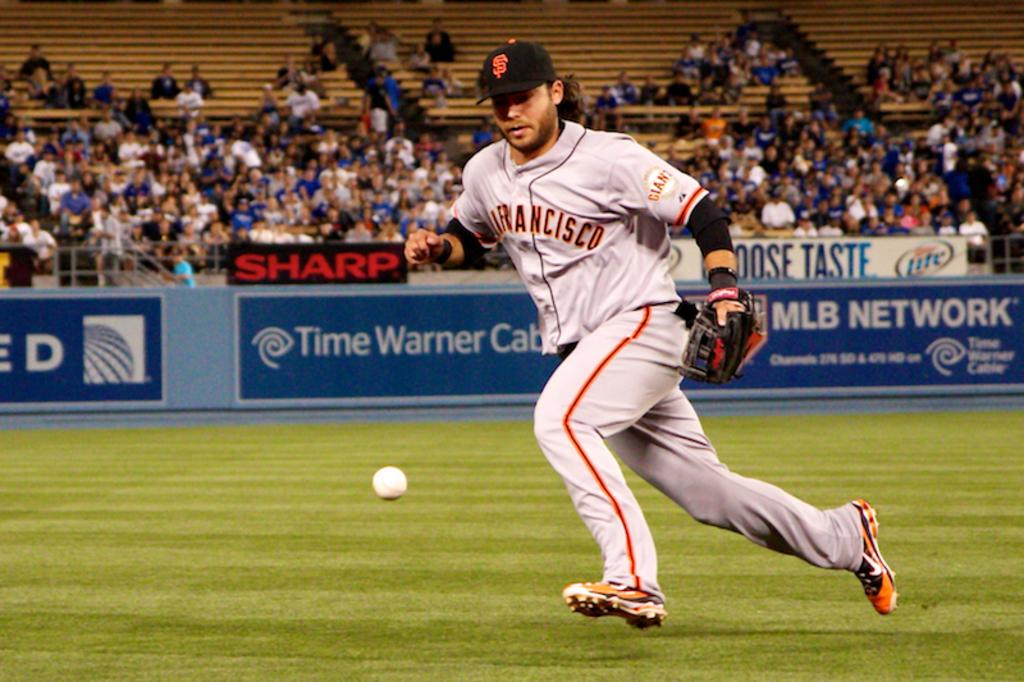<image>
Describe the image concisely. The player is from the San Francisco Giants 